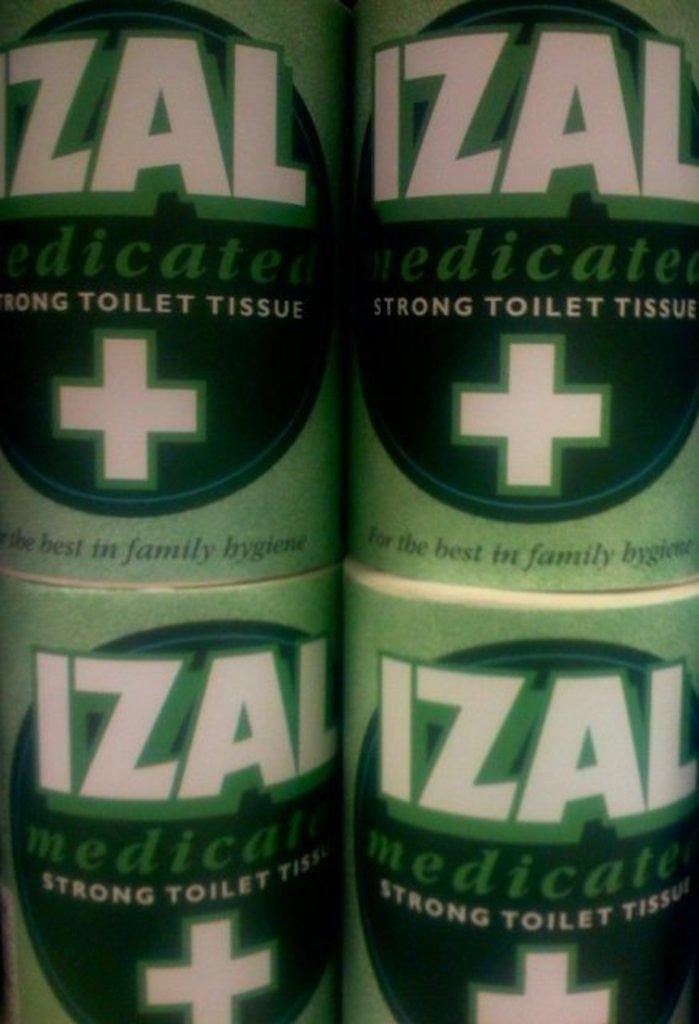<image>
Write a terse but informative summary of the picture. Four Izal toilet tissue rolls stacked on one another. 